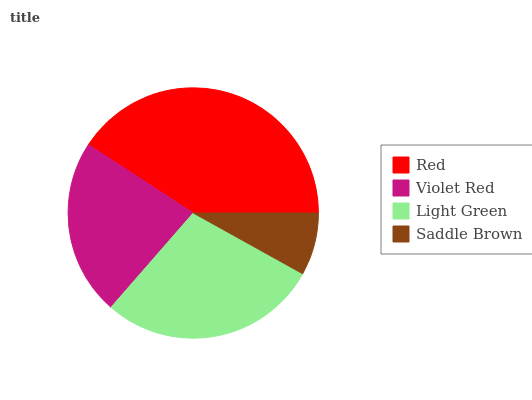Is Saddle Brown the minimum?
Answer yes or no. Yes. Is Red the maximum?
Answer yes or no. Yes. Is Violet Red the minimum?
Answer yes or no. No. Is Violet Red the maximum?
Answer yes or no. No. Is Red greater than Violet Red?
Answer yes or no. Yes. Is Violet Red less than Red?
Answer yes or no. Yes. Is Violet Red greater than Red?
Answer yes or no. No. Is Red less than Violet Red?
Answer yes or no. No. Is Light Green the high median?
Answer yes or no. Yes. Is Violet Red the low median?
Answer yes or no. Yes. Is Saddle Brown the high median?
Answer yes or no. No. Is Light Green the low median?
Answer yes or no. No. 